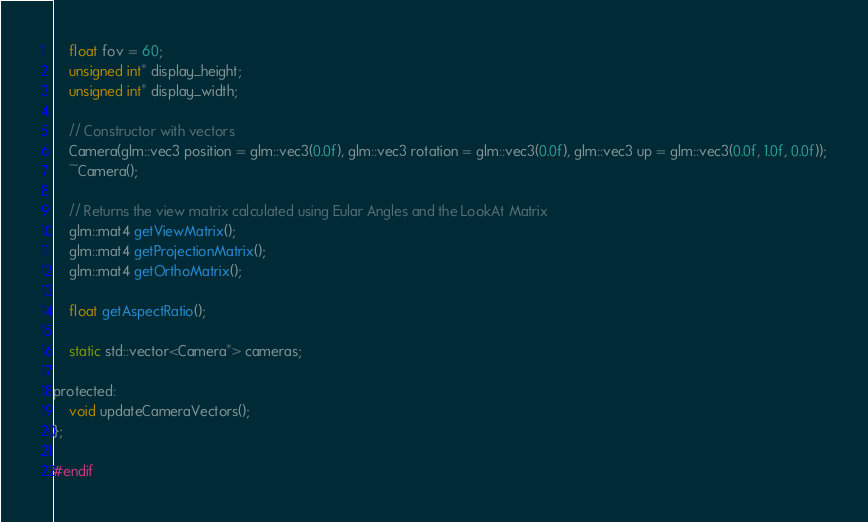Convert code to text. <code><loc_0><loc_0><loc_500><loc_500><_C_>	float fov = 60;
	unsigned int* display_height;
	unsigned int* display_width;

	// Constructor with vectors
	Camera(glm::vec3 position = glm::vec3(0.0f), glm::vec3 rotation = glm::vec3(0.0f), glm::vec3 up = glm::vec3(0.0f, 1.0f, 0.0f));
	~Camera();
	
	// Returns the view matrix calculated using Eular Angles and the LookAt Matrix
	glm::mat4 getViewMatrix();
	glm::mat4 getProjectionMatrix();
	glm::mat4 getOrthoMatrix();

	float getAspectRatio();

	static std::vector<Camera*> cameras;

protected:
	void updateCameraVectors();
};

#endif

</code> 